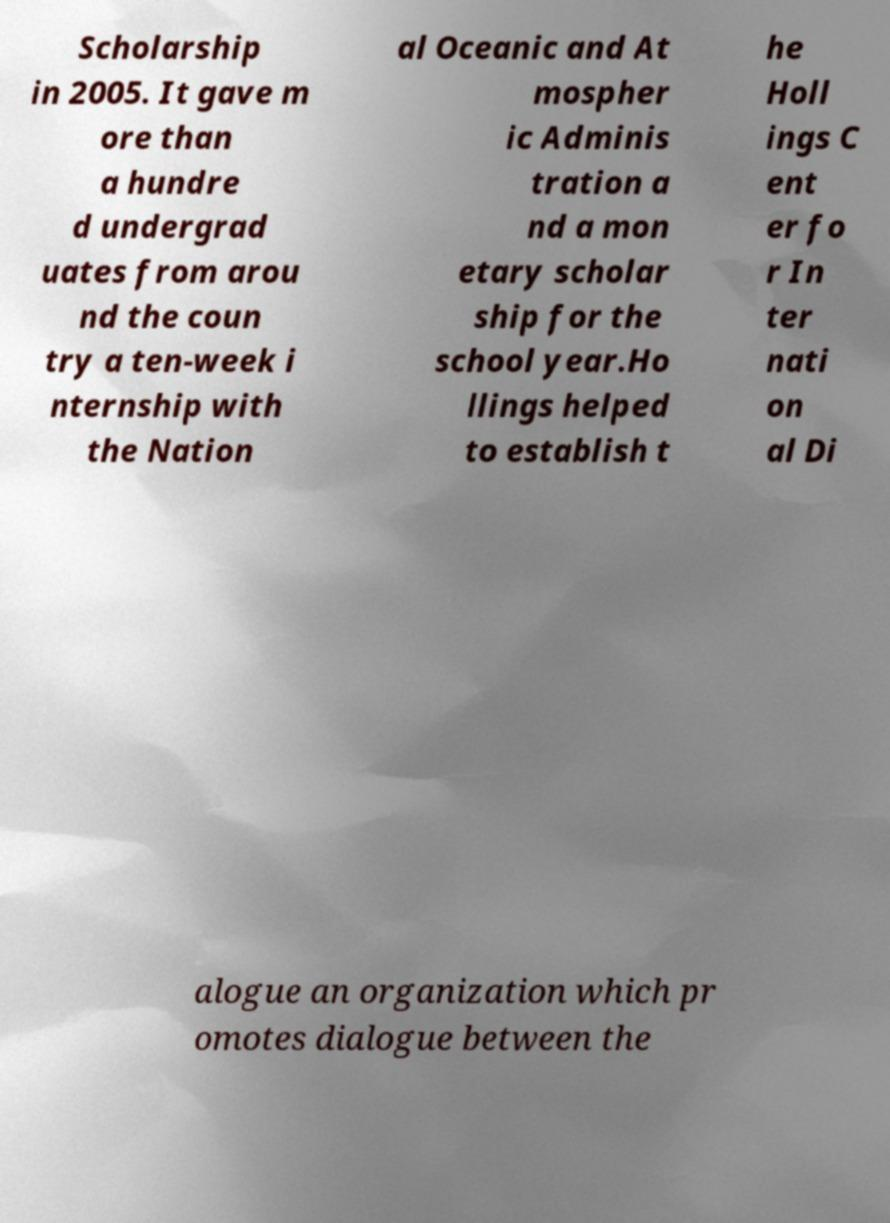Could you extract and type out the text from this image? Scholarship in 2005. It gave m ore than a hundre d undergrad uates from arou nd the coun try a ten-week i nternship with the Nation al Oceanic and At mospher ic Adminis tration a nd a mon etary scholar ship for the school year.Ho llings helped to establish t he Holl ings C ent er fo r In ter nati on al Di alogue an organization which pr omotes dialogue between the 